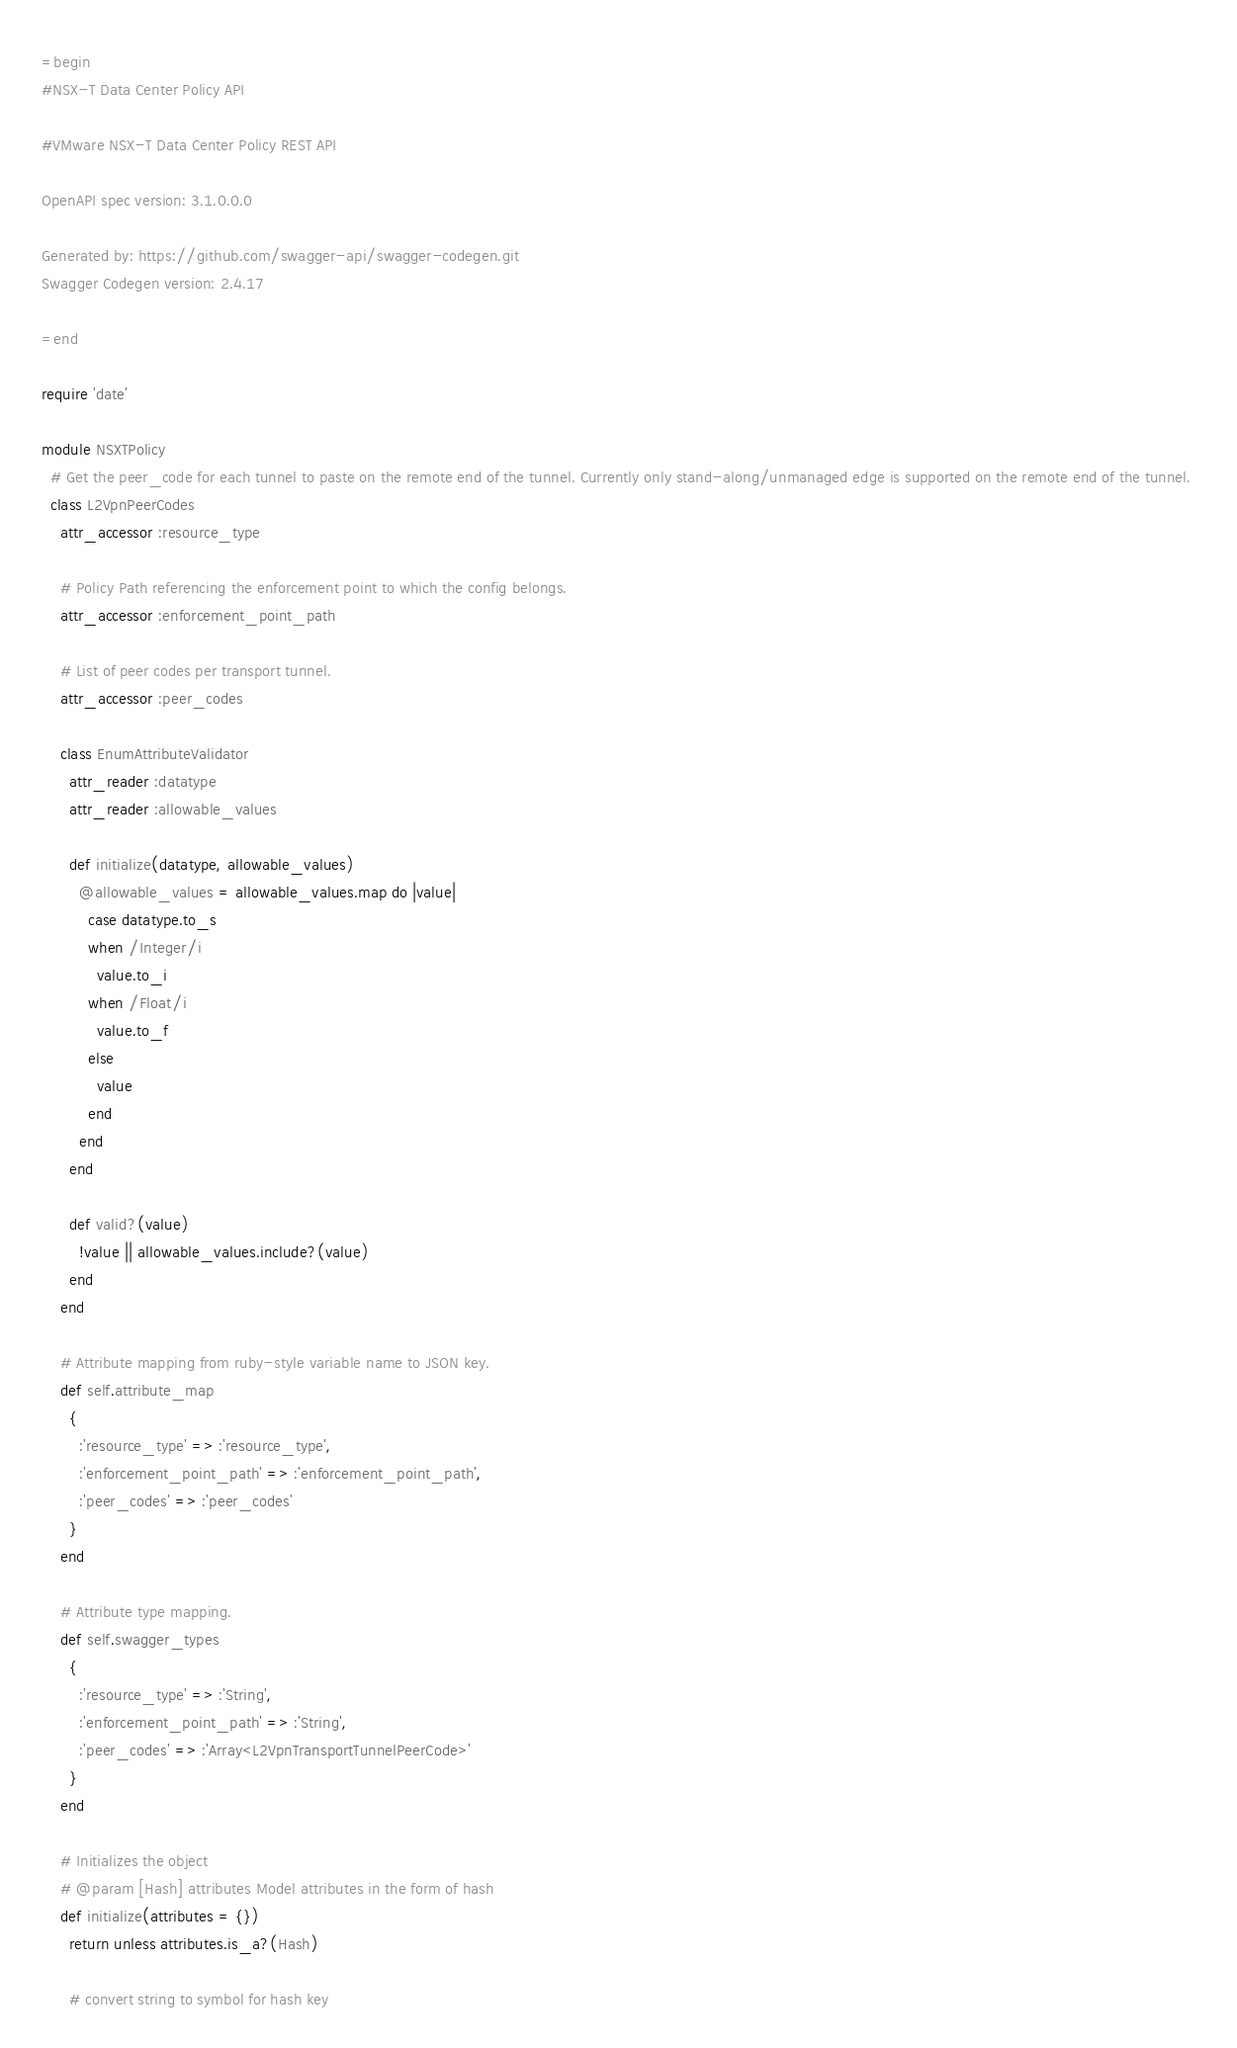<code> <loc_0><loc_0><loc_500><loc_500><_Ruby_>=begin
#NSX-T Data Center Policy API

#VMware NSX-T Data Center Policy REST API

OpenAPI spec version: 3.1.0.0.0

Generated by: https://github.com/swagger-api/swagger-codegen.git
Swagger Codegen version: 2.4.17

=end

require 'date'

module NSXTPolicy
  # Get the peer_code for each tunnel to paste on the remote end of the tunnel. Currently only stand-along/unmanaged edge is supported on the remote end of the tunnel. 
  class L2VpnPeerCodes
    attr_accessor :resource_type

    # Policy Path referencing the enforcement point to which the config belongs. 
    attr_accessor :enforcement_point_path

    # List of peer codes per transport tunnel.
    attr_accessor :peer_codes

    class EnumAttributeValidator
      attr_reader :datatype
      attr_reader :allowable_values

      def initialize(datatype, allowable_values)
        @allowable_values = allowable_values.map do |value|
          case datatype.to_s
          when /Integer/i
            value.to_i
          when /Float/i
            value.to_f
          else
            value
          end
        end
      end

      def valid?(value)
        !value || allowable_values.include?(value)
      end
    end

    # Attribute mapping from ruby-style variable name to JSON key.
    def self.attribute_map
      {
        :'resource_type' => :'resource_type',
        :'enforcement_point_path' => :'enforcement_point_path',
        :'peer_codes' => :'peer_codes'
      }
    end

    # Attribute type mapping.
    def self.swagger_types
      {
        :'resource_type' => :'String',
        :'enforcement_point_path' => :'String',
        :'peer_codes' => :'Array<L2VpnTransportTunnelPeerCode>'
      }
    end

    # Initializes the object
    # @param [Hash] attributes Model attributes in the form of hash
    def initialize(attributes = {})
      return unless attributes.is_a?(Hash)

      # convert string to symbol for hash key</code> 